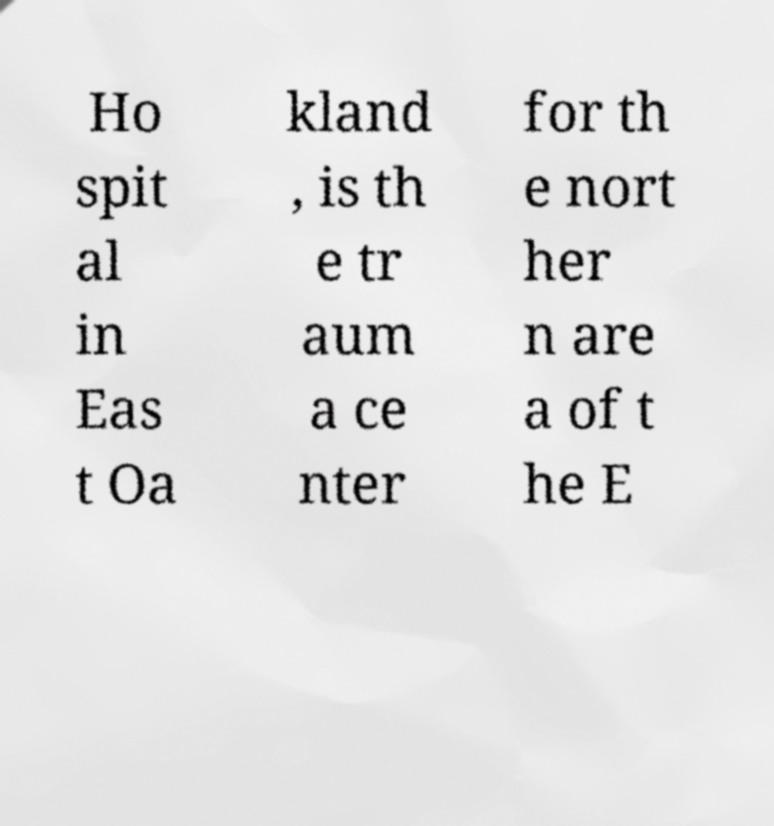For documentation purposes, I need the text within this image transcribed. Could you provide that? Ho spit al in Eas t Oa kland , is th e tr aum a ce nter for th e nort her n are a of t he E 